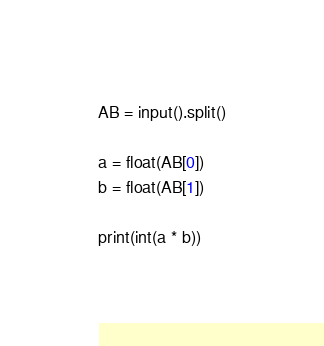Convert code to text. <code><loc_0><loc_0><loc_500><loc_500><_Python_>AB = input().split()

a = float(AB[0])
b = float(AB[1])

print(int(a * b))</code> 